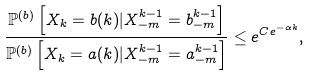Convert formula to latex. <formula><loc_0><loc_0><loc_500><loc_500>\frac { \mathbb { P } ^ { ( b ) } \left [ X _ { k } = b ( k ) | X _ { - m } ^ { k - 1 } = b _ { - m } ^ { k - 1 } \right ] } { \mathbb { P } ^ { ( b ) } \left [ X _ { k } = a ( k ) | X _ { - m } ^ { k - 1 } = a _ { - m } ^ { k - 1 } \right ] } \leq e ^ { C e ^ { - \alpha k } } ,</formula> 